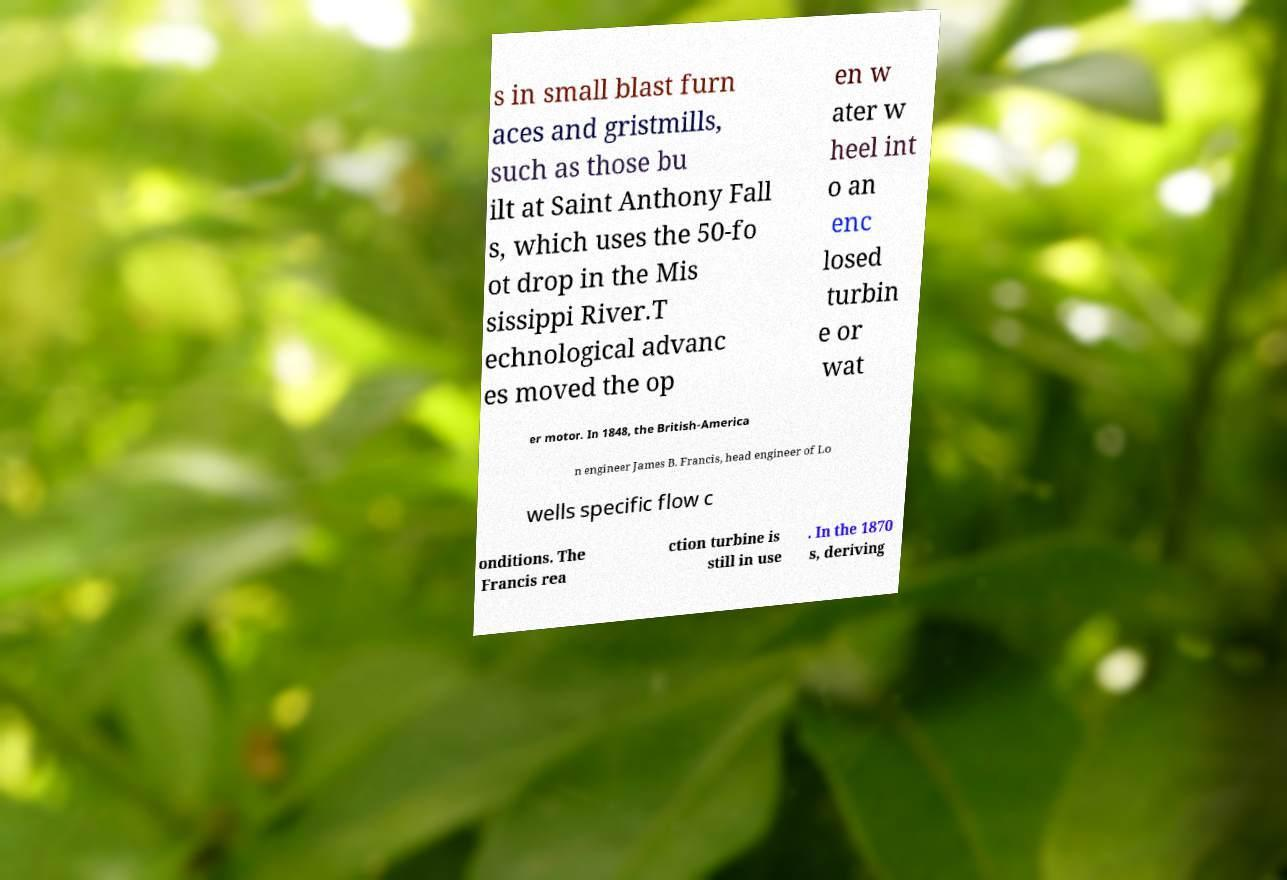There's text embedded in this image that I need extracted. Can you transcribe it verbatim? s in small blast furn aces and gristmills, such as those bu ilt at Saint Anthony Fall s, which uses the 50-fo ot drop in the Mis sissippi River.T echnological advanc es moved the op en w ater w heel int o an enc losed turbin e or wat er motor. In 1848, the British-America n engineer James B. Francis, head engineer of Lo wells specific flow c onditions. The Francis rea ction turbine is still in use . In the 1870 s, deriving 